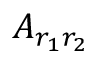<formula> <loc_0><loc_0><loc_500><loc_500>A _ { r _ { 1 } r _ { 2 } }</formula> 